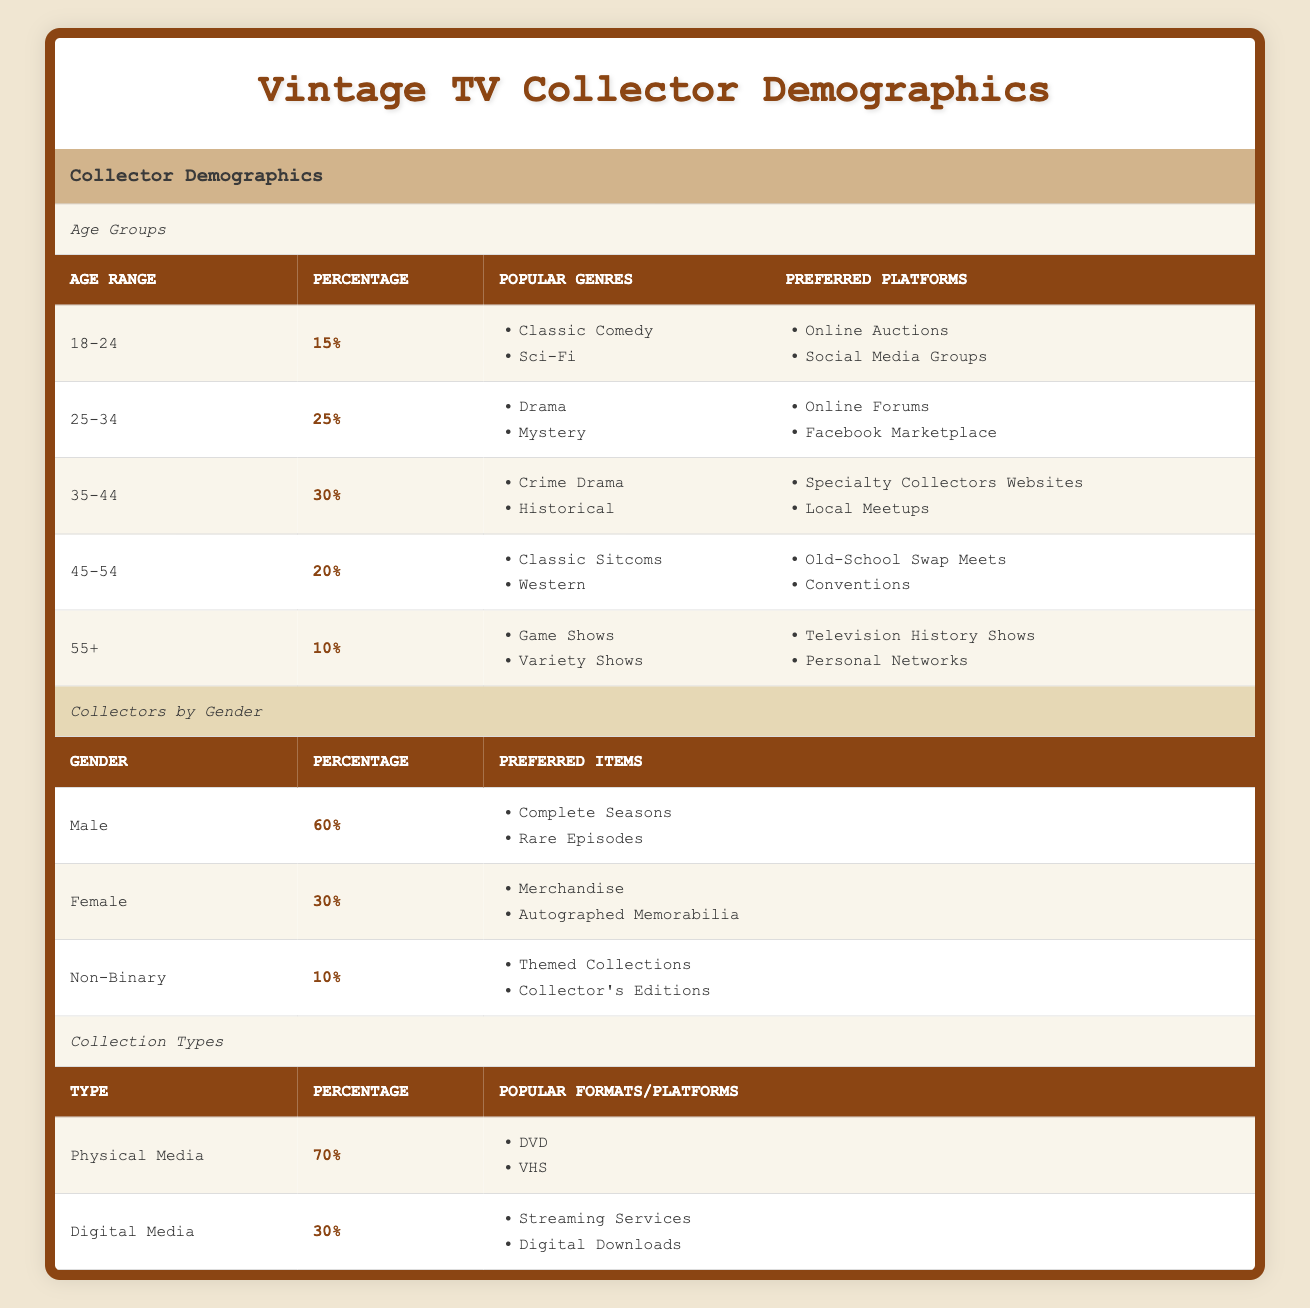What is the percentage of collectors aged 35-44? The table states that the percentage of collectors in the age group 35-44 is 30%.
Answer: 30% Which age group prefers online auctions and social media groups the most? According to the table, the age group 18-24 has preferred platforms that include online auctions and social media groups.
Answer: 18-24 How many total percentage points do male and female collectors represent combined? The male collectors represent 60% and female collectors represent 30%. By adding these together, 60 + 30 equals 90 percentage points.
Answer: 90% Does the majority of collectors prefer physical media format? The table indicates that 70% of collectors prefer physical media, which is indeed the majority, as it is more than 50%.
Answer: Yes In which age group is the percentage of collectors the least, and what is that percentage? The age group 55+ has the least percentage of collectors at 10%, as it is the smallest figure among all other age groups listed.
Answer: 55+, 10% What is the predominant preferred item for male collectors? The table shows that male collectors predominantly prefer complete seasons and rare episodes.
Answer: Complete seasons and rare episodes What are the most popular genres among collectors aged 25-34? For collectors in the age group 25-34, the popular genres listed are drama and mystery.
Answer: Drama and mystery If you take the average percentage of all age groups, what would that value be? To find the average, sum up all the percentages of age groups: 15 + 25 + 30 + 20 + 10 = 100, then divide by 5 (total groups), which yields 20.
Answer: 20 Which gender has a preference for autographed memorabilia? The table notes that female collectors have a preference for items such as autographed memorabilia.
Answer: Female How does the percentage of digital media collectors compare to physical media collectors? The data shows that 30% prefer digital media while 70% prefer physical media. Thus, physical media collectors outnumber digital media collectors by 40 percentage points (70 - 30).
Answer: Physical media collectors outnumber by 40% 